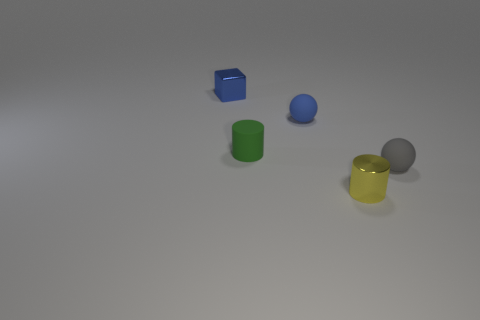Add 4 tiny spheres. How many objects exist? 9 Subtract 0 brown balls. How many objects are left? 5 Subtract all cylinders. How many objects are left? 3 Subtract all purple cylinders. Subtract all gray blocks. How many cylinders are left? 2 Subtract all rubber cylinders. Subtract all tiny cylinders. How many objects are left? 2 Add 1 small blue balls. How many small blue balls are left? 2 Add 5 small blue balls. How many small blue balls exist? 6 